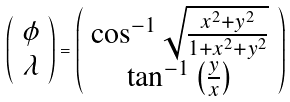Convert formula to latex. <formula><loc_0><loc_0><loc_500><loc_500>\left ( \begin{array} { c } \phi \\ \lambda \end{array} \right ) = \left ( \begin{array} { c } \cos ^ { - 1 } \sqrt { \frac { x ^ { 2 } + y ^ { 2 } } { 1 + x ^ { 2 } + y ^ { 2 } } } \\ \tan ^ { - 1 } \left ( \frac { y } { x } \right ) \end{array} \right )</formula> 